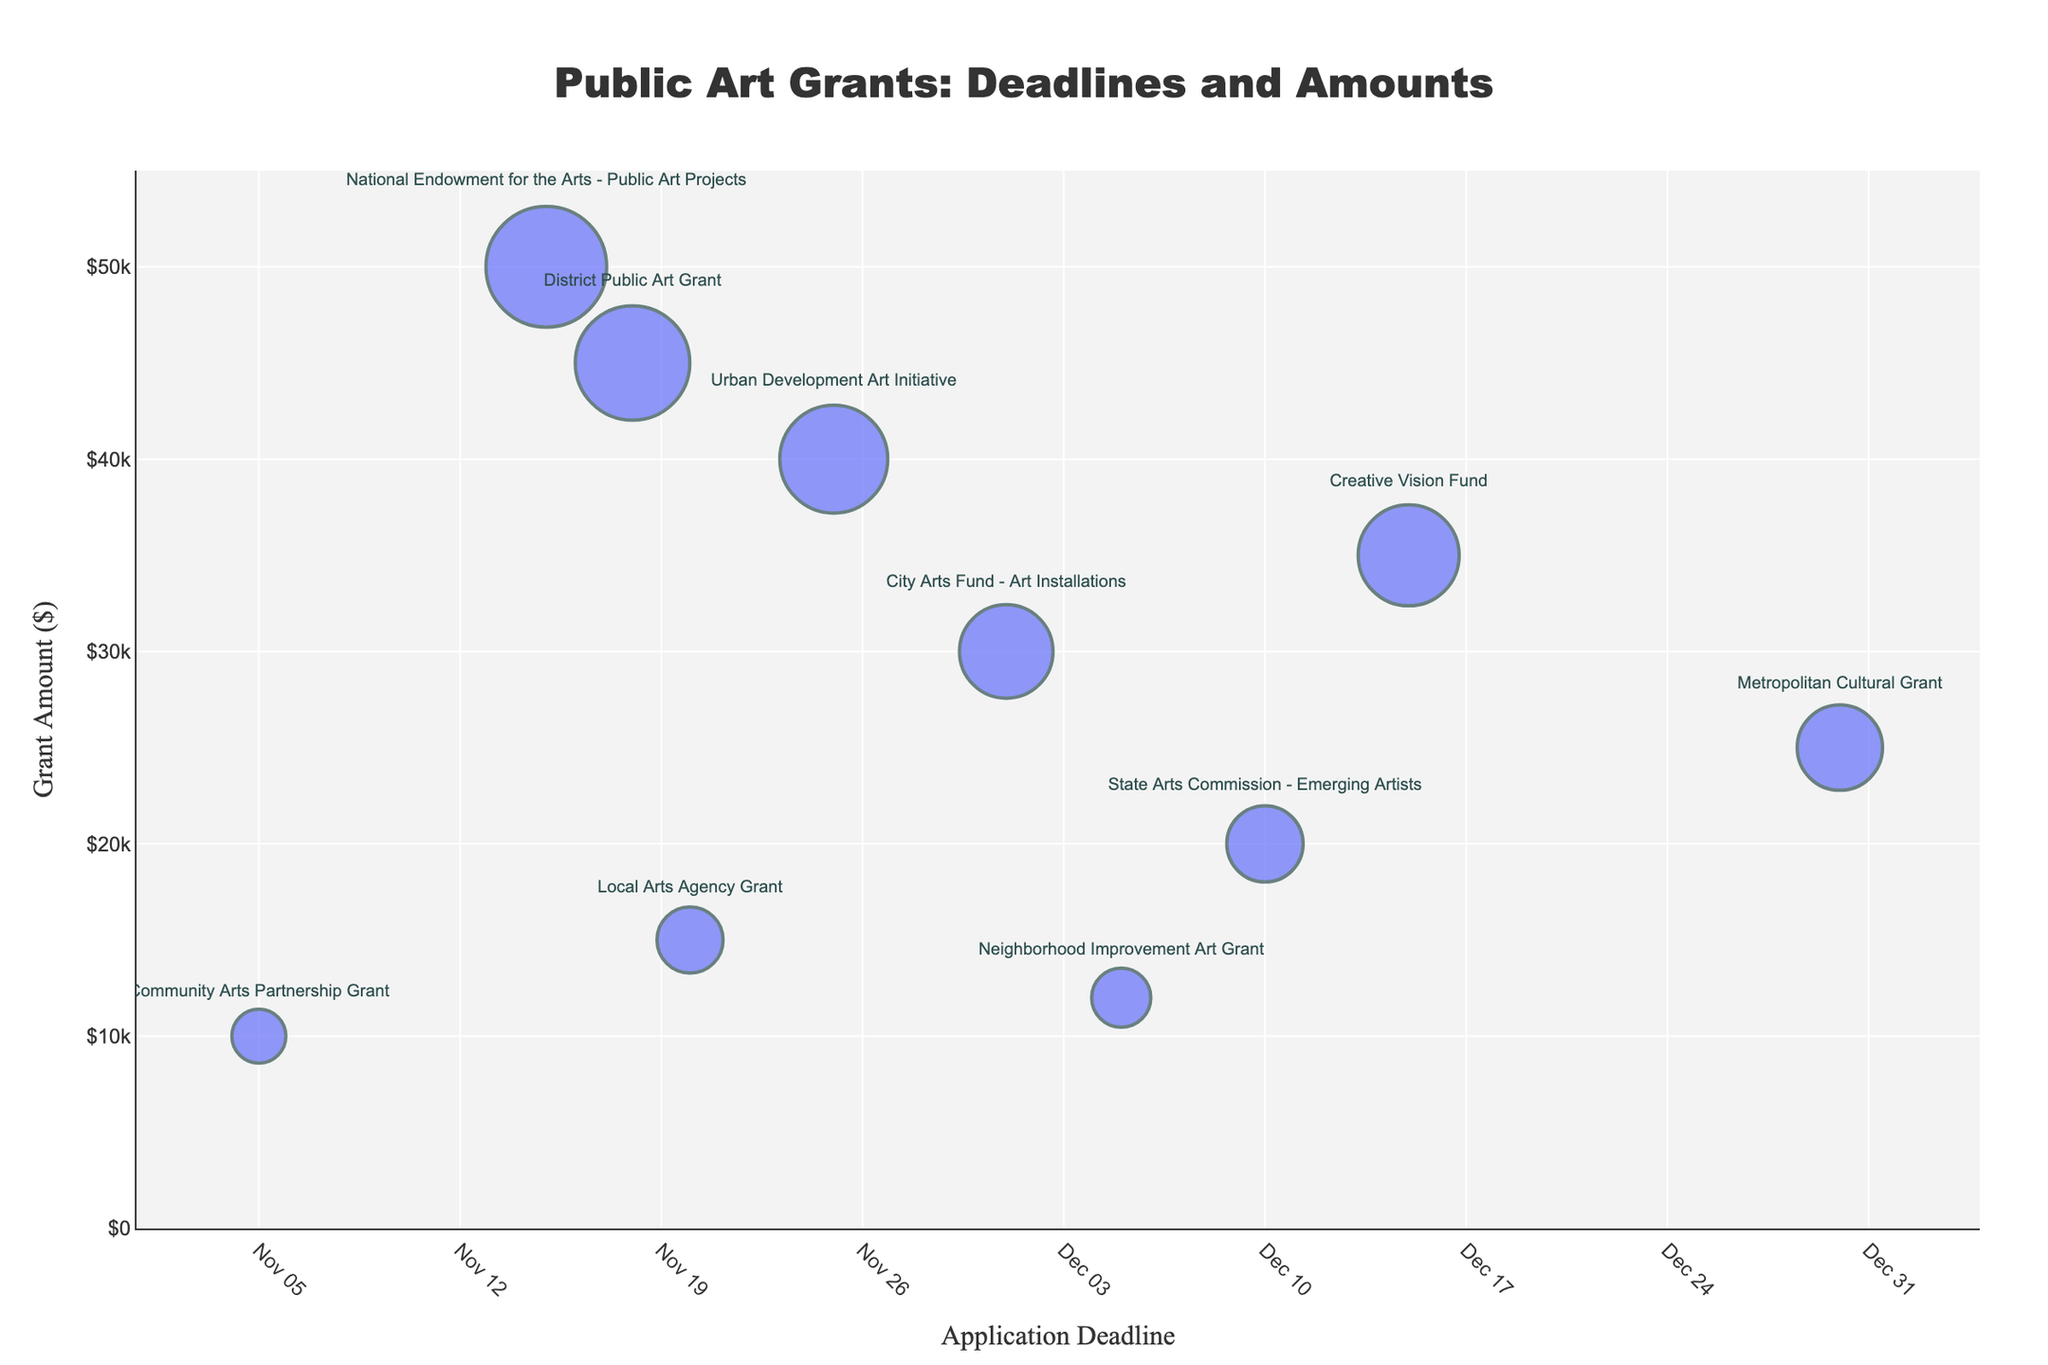Which grant has the highest amount? Look for the bubble with the largest size on the y-axis at the highest point. Hover over it to see its name and the amount.
Answer: National Endowment for the Arts - Public Art Projects What's the title of the chart? The title is typically positioned at the top of the chart. It sums up what the chart is about.
Answer: Public Art Grants: Deadlines and Amounts How many grants have application deadlines in November? Count the number of bubbles positioned within the range of November on the x-axis.
Answer: 6 What's the difference in grant amounts between the highest and lowest grants? Identify the highest and lowest points on the y-axis (National Endowment for the Arts - Public Art Projects at $50,000 and Community Arts Partnership Grant at $10,000) and subtract the smaller from the larger.
Answer: $40,000 Which grant has the earliest application deadline? Look for the bubble at the farthest left on the x-axis, which indicates the earliest date.
Answer: Community Arts Partnership Grant What are the application deadlines for grants offering more than $40,000? Find the bubbles positioned above $40,000 on the y-axis and note their corresponding x-axis dates.
Answer: 2023-11-15, 2023-11-18 How does the grant amount for City Arts Fund - Art Installations compare to Creative Vision Fund? Locate both bubbles and compare their positions on the y-axis. City Arts Fund - Art Installations has a lower position on the y-axis indicating a smaller amount compared to Creative Vision Fund.
Answer: City Arts Fund - Art Installations is less than Creative Vision Fund What is the average grant amount of the grants listed? Sum all grant amounts (50,000 + 30,000 + 15,000 + 20,000 + 10,000 + 25,000 + 40,000 + 35,000 + 45,000 + 12,000) and divide by the number of grants (10).
Answer: $28,200 Which grants are available in December? Find the bubbles positioned in December on the x-axis and list their names.
Answer: City Arts Fund - Art Installations, State Arts Commission - Emerging Artists, Metropolitan Cultural Grant, Creative Vision Fund, Neighborhood Improvement Art Grant What is the grant amount of Urban Development Art Initiative? Hover over the Urban Development Art Initiative bubble and read the y-axis value provided in the hover information.
Answer: $40,000 